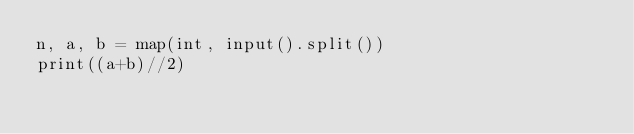<code> <loc_0><loc_0><loc_500><loc_500><_Python_>n, a, b = map(int, input().split())
print((a+b)//2)
</code> 